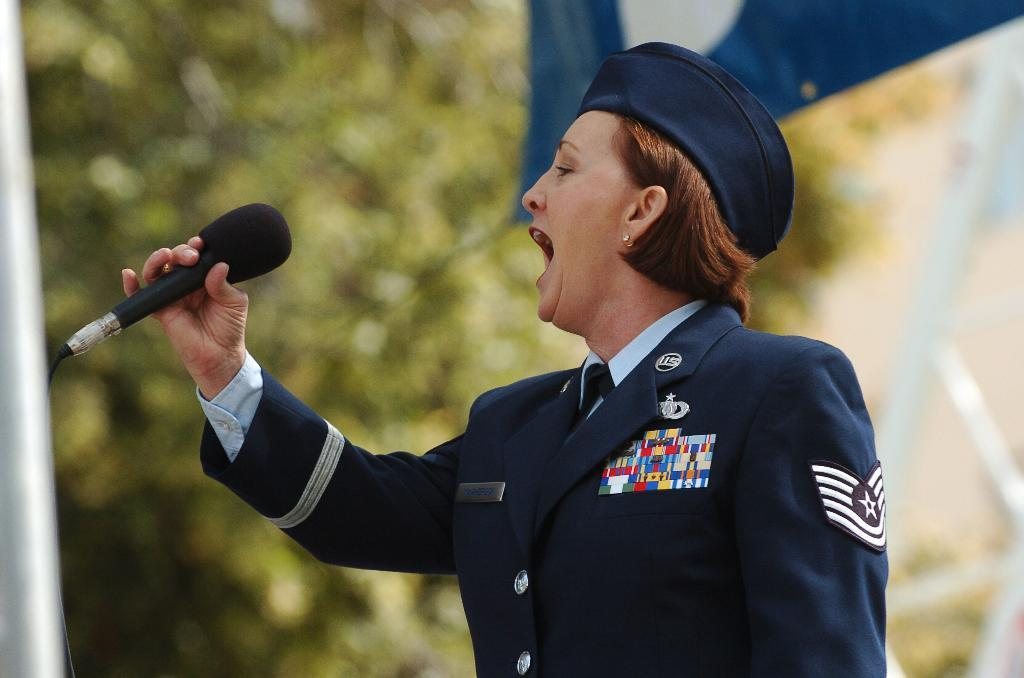Who is the main subject in the image? There is a woman in the center of the image. What is the woman holding in the image? The woman is holding a mic. What can be seen in the background of the image? There is a flag and a tree in the background of the image. What type of riddle can be heard being solved by the pets in the bedroom in the image? There are no pets or bedrooms present in the image, and therefore no riddles can be heard being solved. 